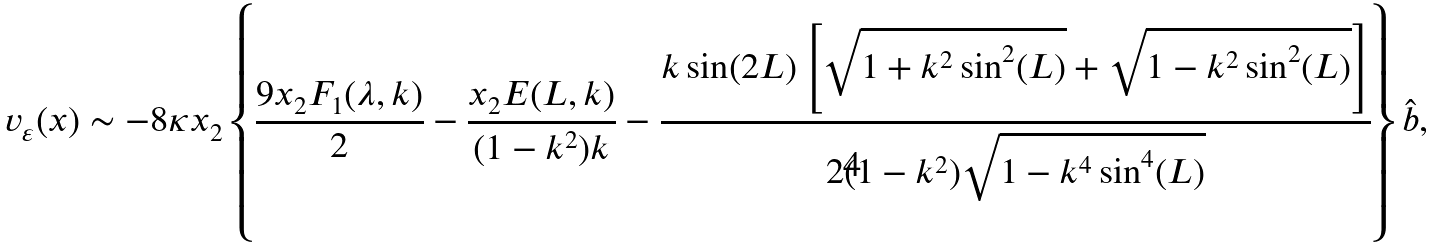<formula> <loc_0><loc_0><loc_500><loc_500>v _ { \varepsilon } ( x ) & \sim - 8 \kappa x _ { 2 } \left \{ \frac { 9 x _ { 2 } F _ { 1 } ( \lambda , k ) } { 2 } - \frac { x _ { 2 } E ( L , k ) } { ( 1 - k ^ { 2 } ) k } - \frac { k \sin ( 2 L ) \left [ \sqrt { 1 + k ^ { 2 } \sin ^ { 2 } ( L ) } + \sqrt { 1 - k ^ { 2 } \sin ^ { 2 } ( L ) } \right ] } { 2 ( 1 - k ^ { 2 } ) \sqrt { 1 - k ^ { 4 } \sin ^ { 4 } ( L ) } } \right \} \hat { b } ,</formula> 